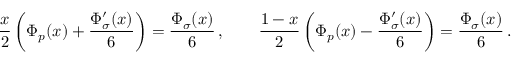<formula> <loc_0><loc_0><loc_500><loc_500>\frac { x } { 2 } \left ( \Phi _ { p } ( x ) + \frac { \Phi _ { \sigma } ^ { \prime } ( x ) } { 6 } \right ) = \frac { \Phi _ { \sigma } ( x ) } { 6 } \, , \quad \frac { 1 - x } { 2 } \left ( \Phi _ { p } ( x ) - \frac { \Phi _ { \sigma } ^ { \prime } ( x ) } { 6 } \right ) = \frac { \Phi _ { \sigma } ( x ) } { 6 } \, .</formula> 